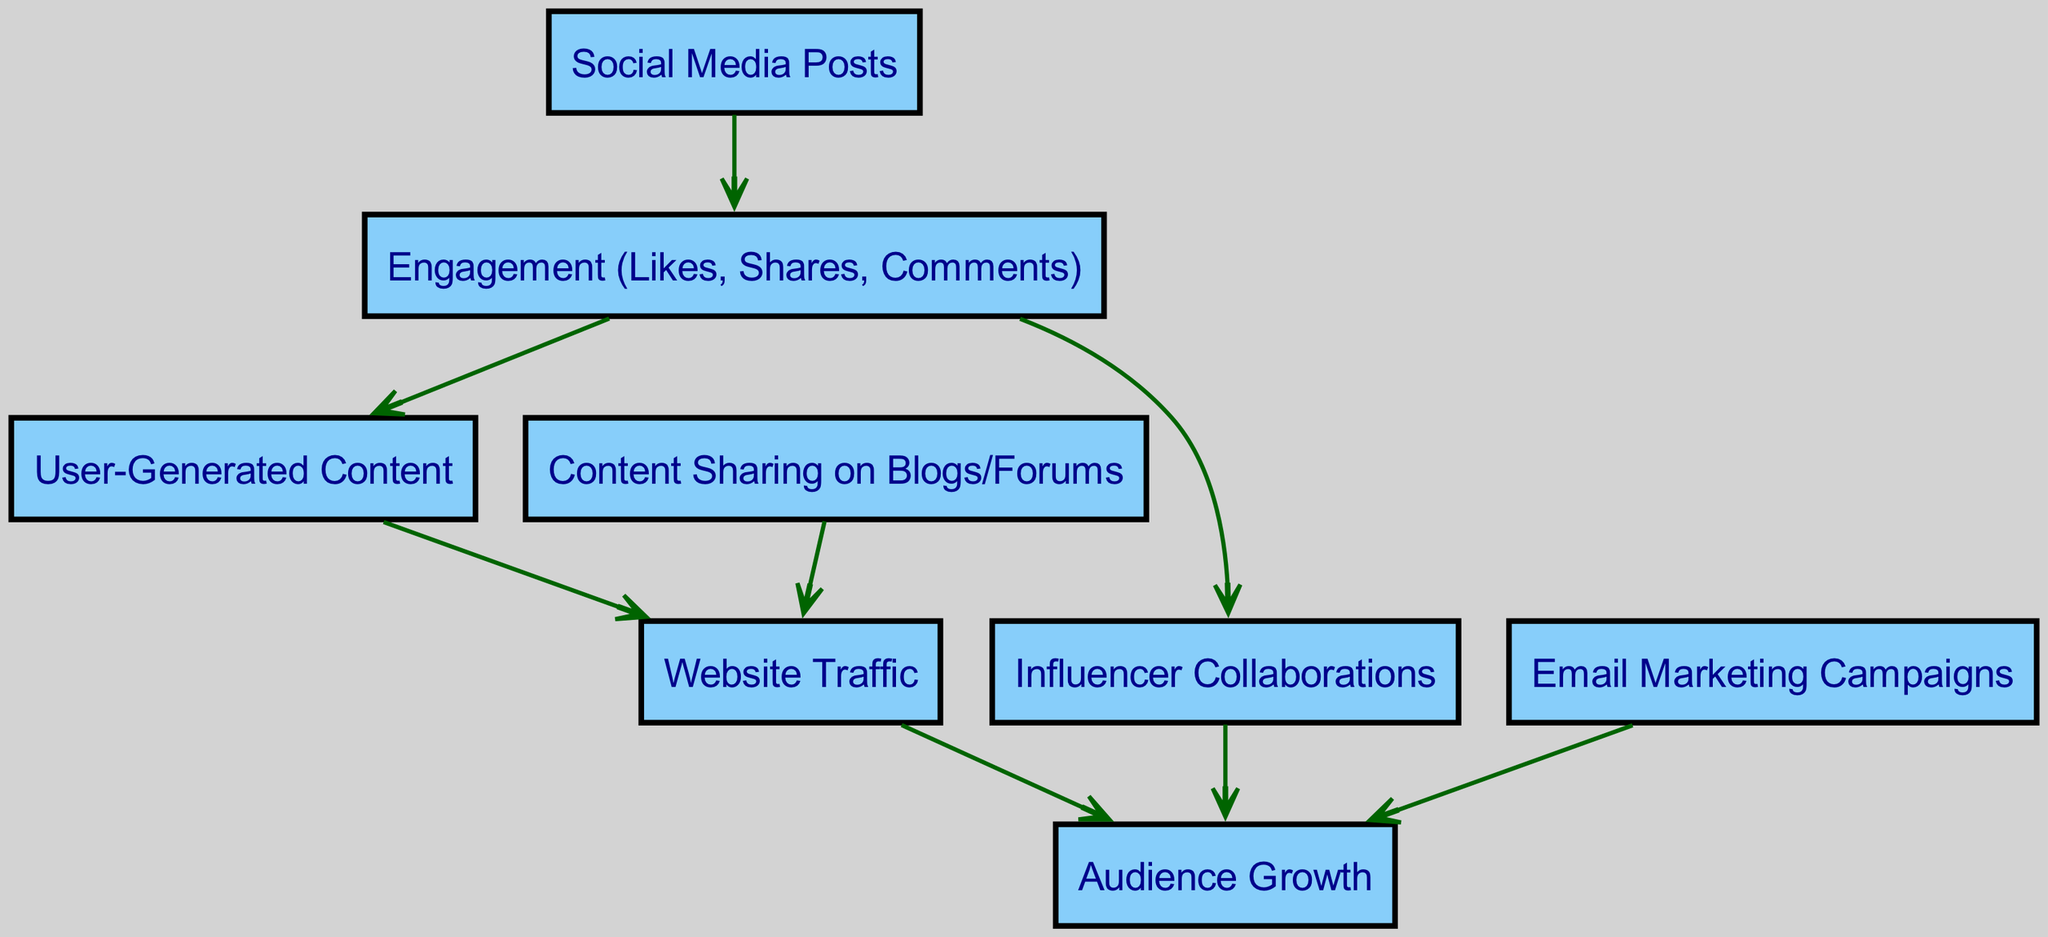What are the total number of nodes in the diagram? The diagram contains eight nodes, which are: Social Media Posts, Engagement, User-Generated Content, Influencer Collaborations, Website Traffic, Email Marketing Campaigns, Audience Growth, and Content Sharing on Blogs/Forums. Counting each of these gives us a total of eight nodes.
Answer: Eight Which node has the highest impact on Audience Growth? The nodes Influencer Collaborations and Website Traffic directly lead to Audience Growth. However, since the diagram suggests multiple paths to Audience Growth, it's reasonable to consider Influencer Collaborations as having a significant and direct impacting role.
Answer: Influencer Collaborations How many edges are connected to the Engagement node? The Engagement node has four outgoing edges: one to User-Generated Content, one to Influencer Collaborations, one to Social Media Posts, and one from Email Marketing. Counting these gives us a total of four edges connected to Engagement.
Answer: Four What node leads to User-Generated Content? The User-Generated Content node is directly connected to the Engagement node, which indicates it is the only node leading to User-Generated Content in this diagram.
Answer: Engagement What is the path from Social Media Posts to Audience Growth? The flow from Social Media Posts starts with Engagement. From Engagement, it leads to Influencer Collaborations and to Website Traffic, both of which eventually lead to Audience Growth. Thus, the path can be described as Social Media Posts → Engagement → Influencer Collaborations → Audience Growth.
Answer: Social Media Posts → Engagement → Influencer Collaborations → Audience Growth Which types of marketing channels contribute to Audience Growth? The channels identified as contributing to Audience Growth in the diagram are Influencer Collaborations and Email Marketing Campaigns. Both nodes directly link to Audience Growth, combining these gives us the answer.
Answer: Influencer Collaborations and Email Marketing Campaigns What is the relationship between Website Traffic and Audience Growth? The Website Traffic node has a direct edge leading to Audience Growth, indicating that increased website traffic positively impacts audience growth. Thus, the relationship is direct and beneficial.
Answer: Direct How does User-Generated Content affect Website Traffic? User-Generated Content has a direct edge leading to Website Traffic. This relationship implies that when users generate content, it drives more traffic to the website, effectively forming a positive correlation.
Answer: Positive correlation 